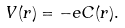<formula> <loc_0><loc_0><loc_500><loc_500>V ( r ) = - e C ( r ) .</formula> 